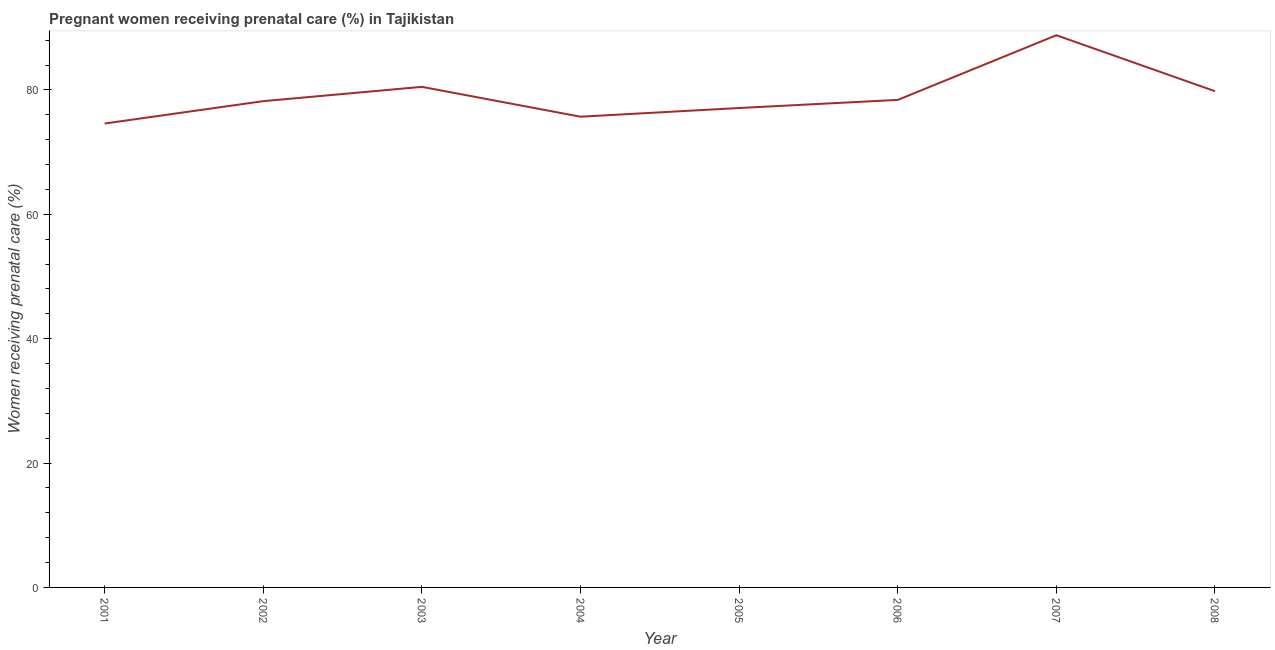What is the percentage of pregnant women receiving prenatal care in 2003?
Ensure brevity in your answer.  80.5. Across all years, what is the maximum percentage of pregnant women receiving prenatal care?
Keep it short and to the point. 88.8. Across all years, what is the minimum percentage of pregnant women receiving prenatal care?
Keep it short and to the point. 74.6. In which year was the percentage of pregnant women receiving prenatal care minimum?
Your answer should be very brief. 2001. What is the sum of the percentage of pregnant women receiving prenatal care?
Provide a short and direct response. 633.1. What is the difference between the percentage of pregnant women receiving prenatal care in 2003 and 2004?
Your answer should be very brief. 4.8. What is the average percentage of pregnant women receiving prenatal care per year?
Your response must be concise. 79.14. What is the median percentage of pregnant women receiving prenatal care?
Make the answer very short. 78.3. What is the ratio of the percentage of pregnant women receiving prenatal care in 2004 to that in 2008?
Your answer should be compact. 0.95. Is the percentage of pregnant women receiving prenatal care in 2004 less than that in 2006?
Your response must be concise. Yes. Is the difference between the percentage of pregnant women receiving prenatal care in 2001 and 2002 greater than the difference between any two years?
Your answer should be very brief. No. What is the difference between the highest and the second highest percentage of pregnant women receiving prenatal care?
Provide a succinct answer. 8.3. What is the difference between the highest and the lowest percentage of pregnant women receiving prenatal care?
Ensure brevity in your answer.  14.2. Does the percentage of pregnant women receiving prenatal care monotonically increase over the years?
Make the answer very short. No. How many lines are there?
Keep it short and to the point. 1. How many years are there in the graph?
Keep it short and to the point. 8. What is the difference between two consecutive major ticks on the Y-axis?
Your answer should be compact. 20. Are the values on the major ticks of Y-axis written in scientific E-notation?
Your answer should be very brief. No. Does the graph contain grids?
Provide a succinct answer. No. What is the title of the graph?
Offer a very short reply. Pregnant women receiving prenatal care (%) in Tajikistan. What is the label or title of the Y-axis?
Your answer should be compact. Women receiving prenatal care (%). What is the Women receiving prenatal care (%) of 2001?
Offer a very short reply. 74.6. What is the Women receiving prenatal care (%) of 2002?
Your answer should be very brief. 78.2. What is the Women receiving prenatal care (%) of 2003?
Provide a succinct answer. 80.5. What is the Women receiving prenatal care (%) in 2004?
Give a very brief answer. 75.7. What is the Women receiving prenatal care (%) in 2005?
Provide a succinct answer. 77.1. What is the Women receiving prenatal care (%) in 2006?
Offer a very short reply. 78.4. What is the Women receiving prenatal care (%) of 2007?
Offer a very short reply. 88.8. What is the Women receiving prenatal care (%) of 2008?
Offer a very short reply. 79.8. What is the difference between the Women receiving prenatal care (%) in 2001 and 2002?
Make the answer very short. -3.6. What is the difference between the Women receiving prenatal care (%) in 2001 and 2003?
Provide a short and direct response. -5.9. What is the difference between the Women receiving prenatal care (%) in 2001 and 2004?
Give a very brief answer. -1.1. What is the difference between the Women receiving prenatal care (%) in 2001 and 2005?
Offer a terse response. -2.5. What is the difference between the Women receiving prenatal care (%) in 2001 and 2006?
Your answer should be very brief. -3.8. What is the difference between the Women receiving prenatal care (%) in 2001 and 2007?
Offer a very short reply. -14.2. What is the difference between the Women receiving prenatal care (%) in 2002 and 2003?
Provide a short and direct response. -2.3. What is the difference between the Women receiving prenatal care (%) in 2002 and 2004?
Provide a succinct answer. 2.5. What is the difference between the Women receiving prenatal care (%) in 2002 and 2005?
Ensure brevity in your answer.  1.1. What is the difference between the Women receiving prenatal care (%) in 2002 and 2006?
Your answer should be compact. -0.2. What is the difference between the Women receiving prenatal care (%) in 2003 and 2004?
Your response must be concise. 4.8. What is the difference between the Women receiving prenatal care (%) in 2003 and 2006?
Your answer should be very brief. 2.1. What is the difference between the Women receiving prenatal care (%) in 2003 and 2007?
Offer a terse response. -8.3. What is the difference between the Women receiving prenatal care (%) in 2003 and 2008?
Provide a succinct answer. 0.7. What is the difference between the Women receiving prenatal care (%) in 2004 and 2008?
Keep it short and to the point. -4.1. What is the difference between the Women receiving prenatal care (%) in 2005 and 2006?
Your answer should be very brief. -1.3. What is the difference between the Women receiving prenatal care (%) in 2005 and 2008?
Make the answer very short. -2.7. What is the difference between the Women receiving prenatal care (%) in 2006 and 2007?
Give a very brief answer. -10.4. What is the difference between the Women receiving prenatal care (%) in 2007 and 2008?
Make the answer very short. 9. What is the ratio of the Women receiving prenatal care (%) in 2001 to that in 2002?
Your answer should be compact. 0.95. What is the ratio of the Women receiving prenatal care (%) in 2001 to that in 2003?
Your response must be concise. 0.93. What is the ratio of the Women receiving prenatal care (%) in 2001 to that in 2006?
Give a very brief answer. 0.95. What is the ratio of the Women receiving prenatal care (%) in 2001 to that in 2007?
Provide a short and direct response. 0.84. What is the ratio of the Women receiving prenatal care (%) in 2001 to that in 2008?
Your response must be concise. 0.94. What is the ratio of the Women receiving prenatal care (%) in 2002 to that in 2003?
Keep it short and to the point. 0.97. What is the ratio of the Women receiving prenatal care (%) in 2002 to that in 2004?
Give a very brief answer. 1.03. What is the ratio of the Women receiving prenatal care (%) in 2002 to that in 2005?
Your answer should be very brief. 1.01. What is the ratio of the Women receiving prenatal care (%) in 2002 to that in 2007?
Ensure brevity in your answer.  0.88. What is the ratio of the Women receiving prenatal care (%) in 2002 to that in 2008?
Keep it short and to the point. 0.98. What is the ratio of the Women receiving prenatal care (%) in 2003 to that in 2004?
Ensure brevity in your answer.  1.06. What is the ratio of the Women receiving prenatal care (%) in 2003 to that in 2005?
Give a very brief answer. 1.04. What is the ratio of the Women receiving prenatal care (%) in 2003 to that in 2007?
Offer a terse response. 0.91. What is the ratio of the Women receiving prenatal care (%) in 2003 to that in 2008?
Your response must be concise. 1.01. What is the ratio of the Women receiving prenatal care (%) in 2004 to that in 2007?
Give a very brief answer. 0.85. What is the ratio of the Women receiving prenatal care (%) in 2004 to that in 2008?
Provide a short and direct response. 0.95. What is the ratio of the Women receiving prenatal care (%) in 2005 to that in 2006?
Provide a short and direct response. 0.98. What is the ratio of the Women receiving prenatal care (%) in 2005 to that in 2007?
Ensure brevity in your answer.  0.87. What is the ratio of the Women receiving prenatal care (%) in 2005 to that in 2008?
Offer a very short reply. 0.97. What is the ratio of the Women receiving prenatal care (%) in 2006 to that in 2007?
Make the answer very short. 0.88. What is the ratio of the Women receiving prenatal care (%) in 2006 to that in 2008?
Provide a succinct answer. 0.98. What is the ratio of the Women receiving prenatal care (%) in 2007 to that in 2008?
Provide a succinct answer. 1.11. 